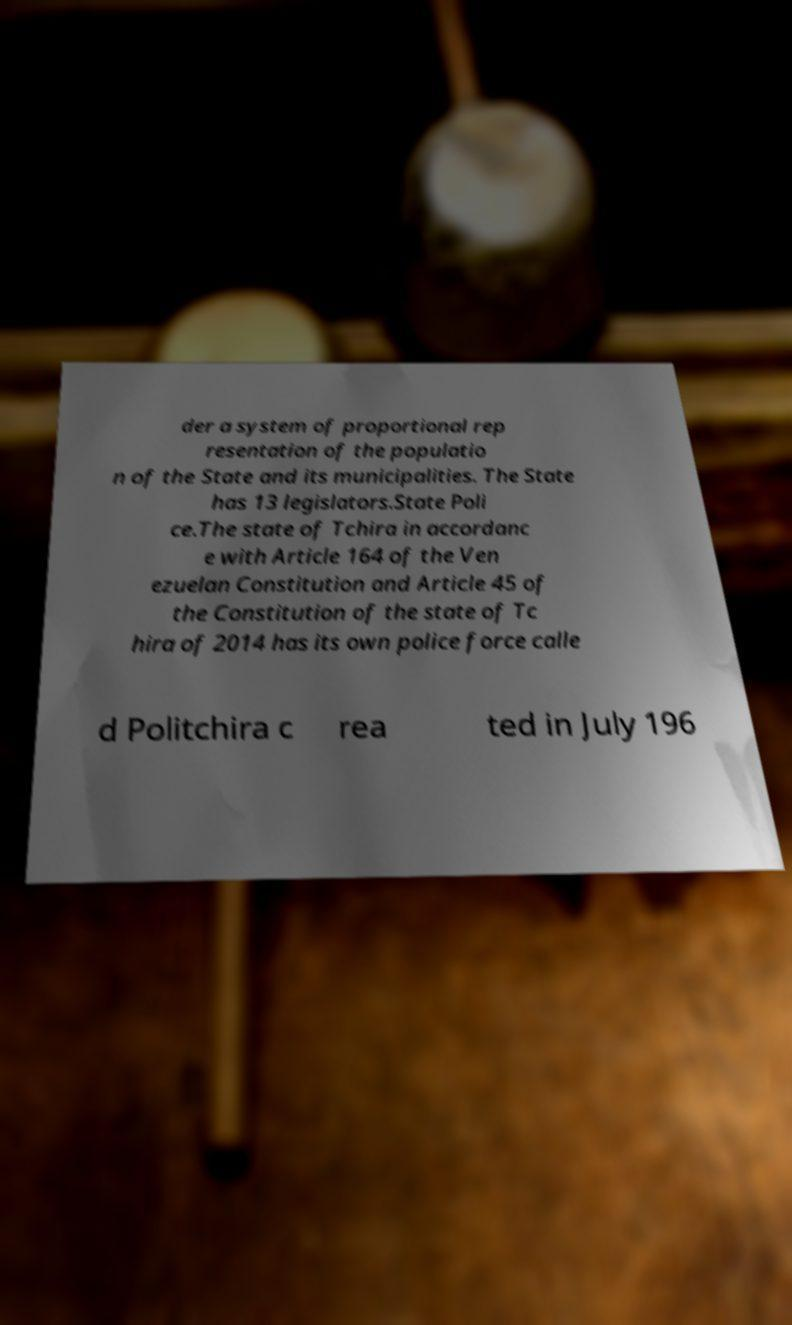For documentation purposes, I need the text within this image transcribed. Could you provide that? der a system of proportional rep resentation of the populatio n of the State and its municipalities. The State has 13 legislators.State Poli ce.The state of Tchira in accordanc e with Article 164 of the Ven ezuelan Constitution and Article 45 of the Constitution of the state of Tc hira of 2014 has its own police force calle d Politchira c rea ted in July 196 